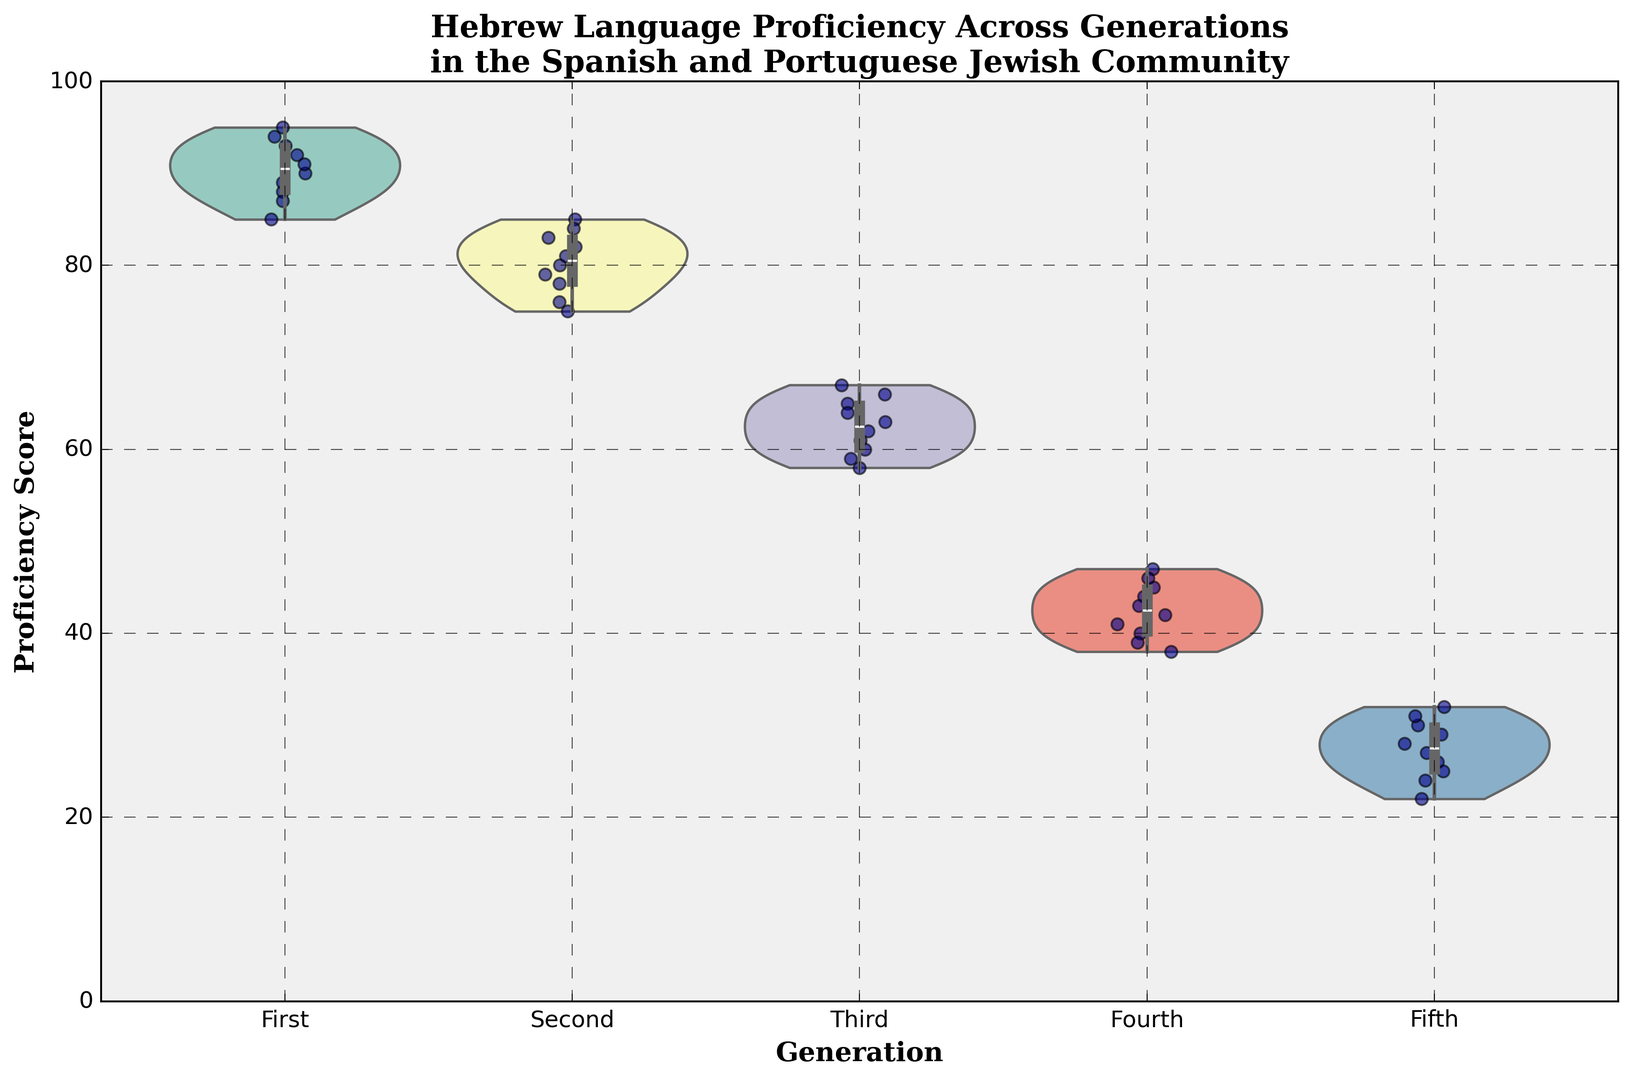What are the median proficiency scores for each generation? To find the median proficiency scores, locate the midpoint of the data distribution for each generation in the violin plot. The medians are represented by markers or lines within each violin shape.
Answer: First: 90, Second: 80, Third: 63, Fourth: 42, Fifth: 27 Which generation shows the largest range in proficiency scores? The range is the difference between the maximum and minimum proficiency scores within a generation. Examine the spread of the violin plots' vertical extent for each generation. The First generation has the largest visible range, stretching from around 85 to 95.
Answer: First How does the average proficiency score of the Fourth generation compare to that of the Second generation? Calculate the average proficiency score for both generations by adding all scores and dividing by the number of scores in each generation. The average for the Second generation appears higher than the Fourth generation visibly.
Answer: Second > Fourth Between the Third and Fifth generations, which one has a more concentrated (less variable) proficiency distribution? Examine the width of the violin plot for each generation. Narrower plots indicate less variability. The Fifth generation's plot is narrow in comparison to the Third, indicating less variability.
Answer: Fifth What can be inferred from the shape of the First generation's violin plot compared to the Fifth generation's plot in terms of proficiency score distribution? The First generation’s violin plot is wider and more evenly spread, indicating a relatively uniform distribution with a higher central concentration around the middle scores, while the Fifth generation has a narrow and peaked shape, suggesting most scores are closely clustered around the median.
Answer: First: Evenly Spread, Fifth: Clustered Which generation has the highest median proficiency score, and what is that score? Look for the generation with the highest centrally located point within the violin plot. The First generation has the highest median score, which is around 90.
Answer: First, 90 Are there any generations where the proficiency scores do not exceed 50? Check the top of the violin plots for each generation. The Fifth generation plot does not reach beyond 50.
Answer: Fifth Which generation shows the most symmetric distribution of proficiency scores? Symmetric distributions appear as mirror images around the center in the violin plot. The First generation shows the most symmetric distribution around its median.
Answer: First 